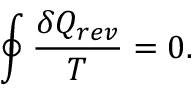Convert formula to latex. <formula><loc_0><loc_0><loc_500><loc_500>\oint { \frac { \delta Q _ { r e v } } { T } } = 0 .</formula> 